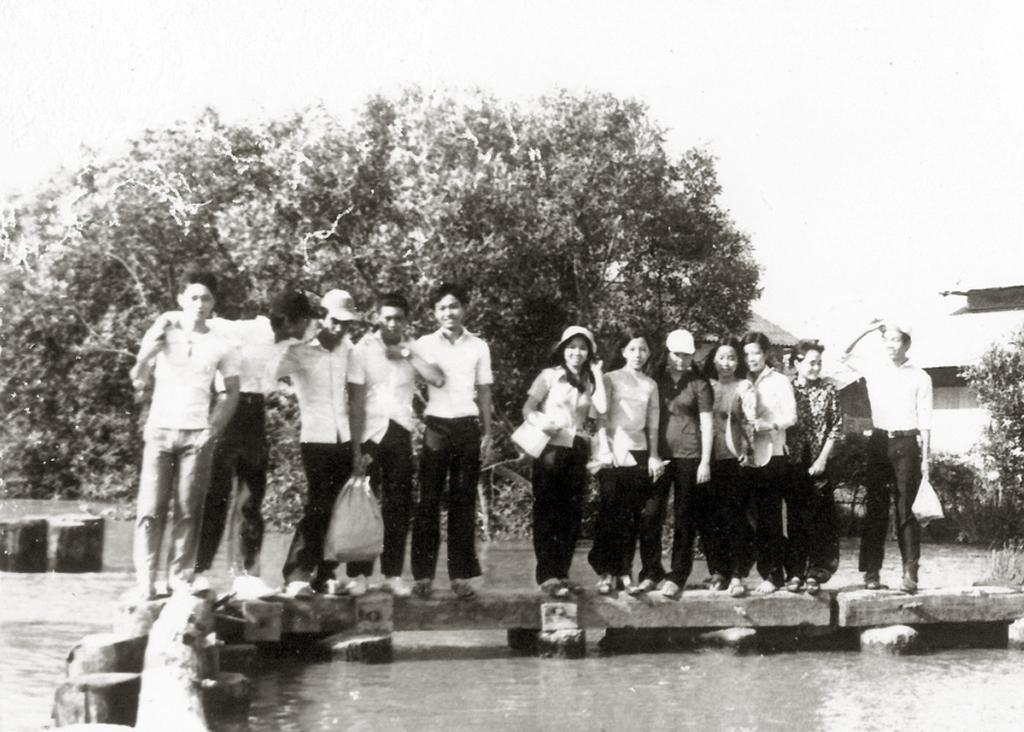What is the main element present in the image? There is water in the image. What are the people standing on in the image? The people are standing on a wooden platform. What can be seen in the background of the image? There are trees, buildings, and the sky visible in the background of the image. What does the writer smell in the image? There is no writer present in the image, so it is not possible to determine what they might smell. 